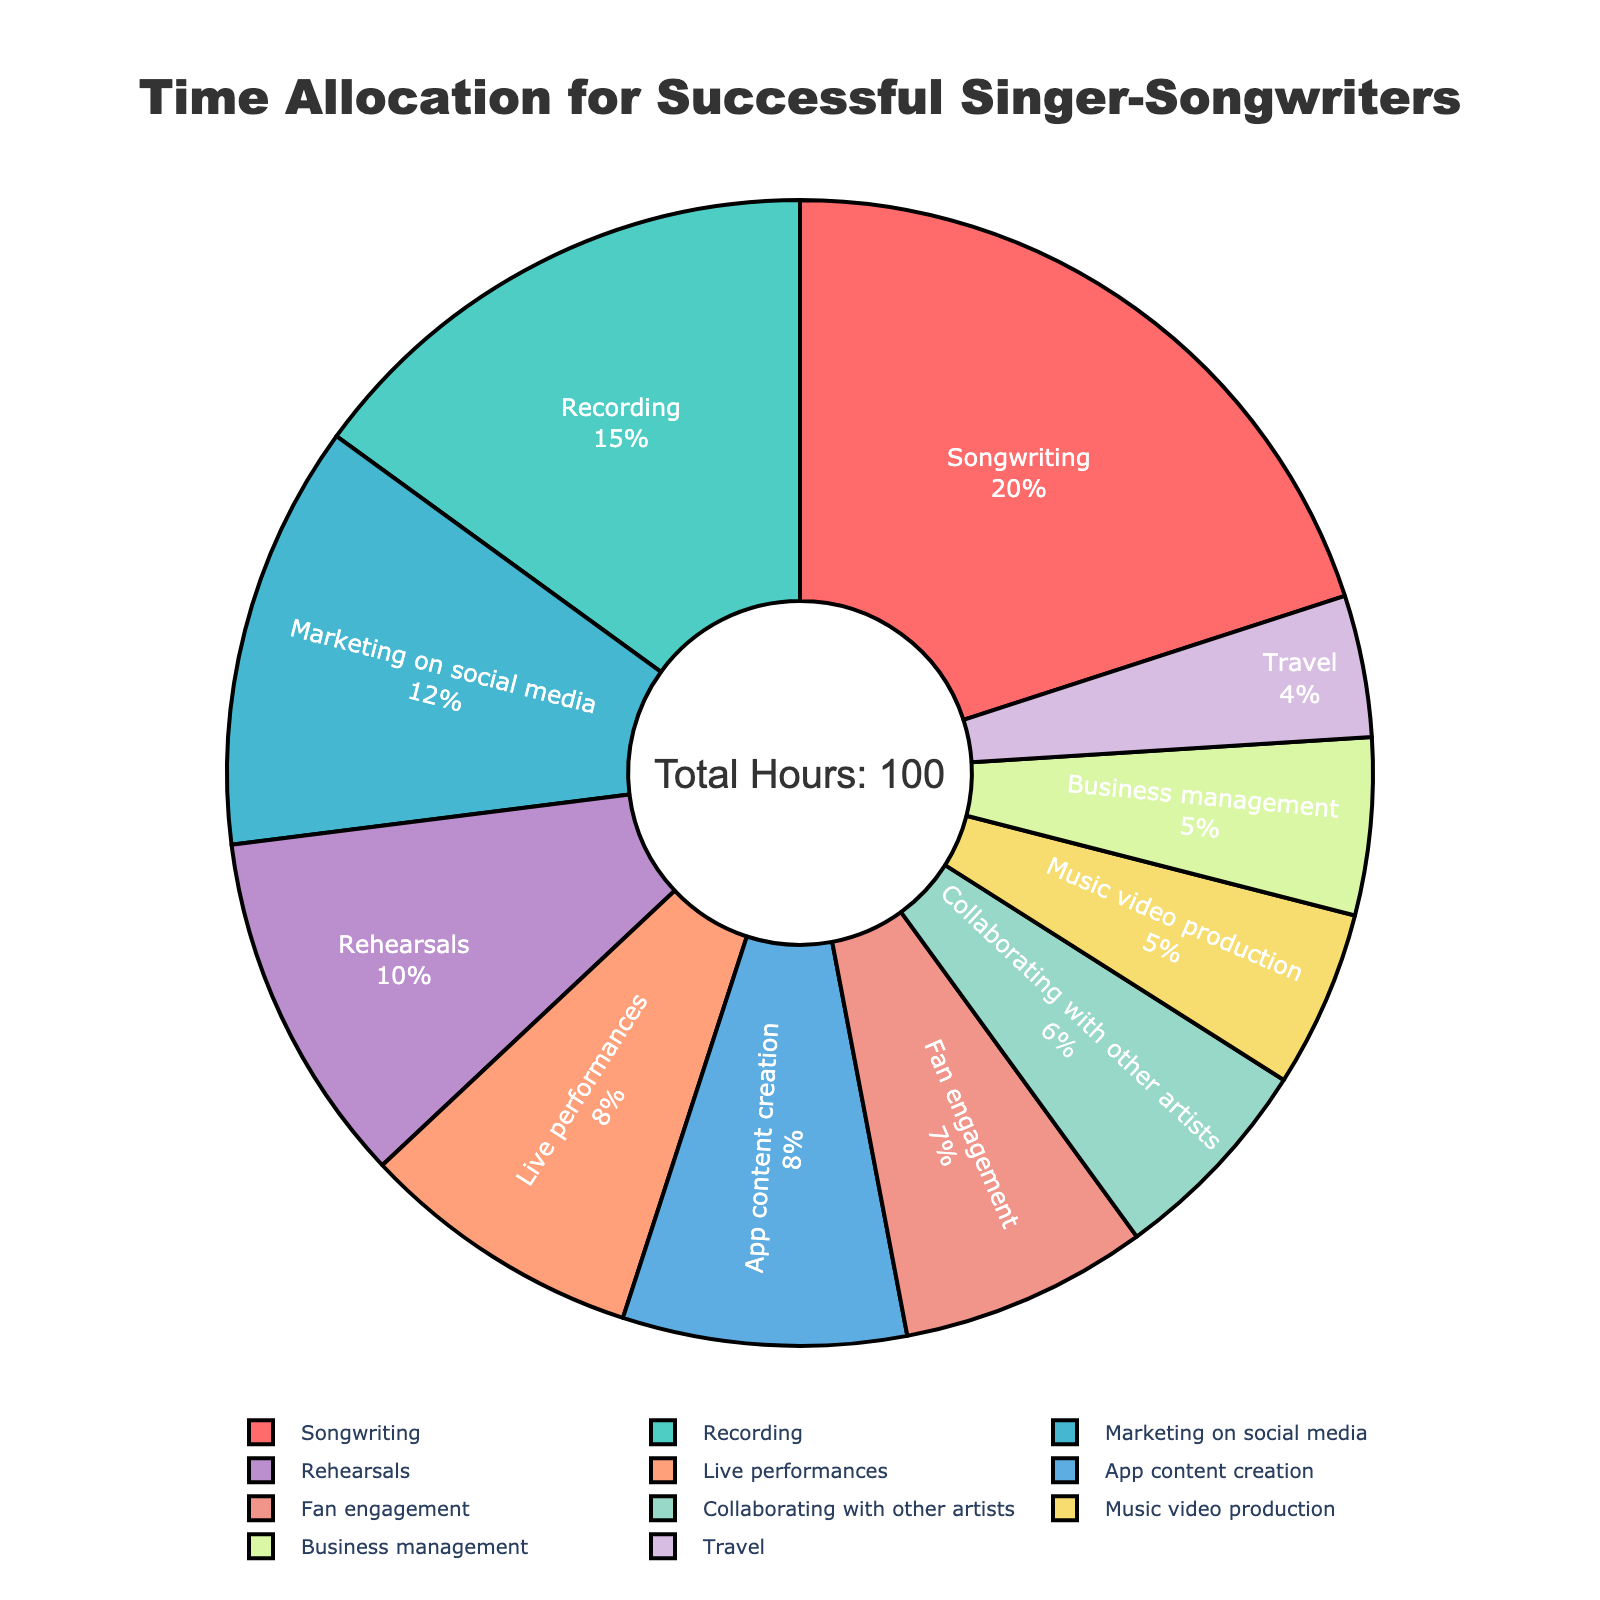Which activity takes up the most time in a typical week for singer-songwriters? By looking at the pie chart, we identify the section with the largest percentage. The label "Songwriting" has the largest portion, representing the highest number of hours.
Answer: Songwriting Which activity takes up the least time? We find the smallest segment of the pie chart by comparing all sections. The label "Travel" represents the smallest portion.
Answer: Travel How much more time is spent on songwriting compared to rehearsals? The writing time is 20 hours and rehearsals are 10 hours. Subtracting them gives 20 - 10 = 10 hours more.
Answer: 10 hours What is the combined percentage of time spent on fan engagement and app content creation? The chart shows the percentages for each segment. Adding fan engagement (7 hours) and app content creation (8 hours) out of 100 total hours gives (7 + 8) / 100 = 15%.
Answer: 15% How does the time allocated to performing compare to marketing on social media? The pie chart shows 8 hours for live performances and 12 hours for marketing. Hence, more hours are allocated to marketing.
Answer: Marketing Which activity is represented by the blue segment? By observing the color-coded sections, the blue segment corresponds with the "Recording" label.
Answer: Recording Is the total time spent on business management and travel more or less than music video production? Business management is 5 hours, travel is 4 hours, and music video production is 5 hours. Summing the first two gives 5+4=9, which is more than 5.
Answer: More What percentage of time is spent on collaborating with other artists? By looking at the pie chart, we find the section labeled "Collaborating with other artists" and annotate its percentage. This is 6%.
Answer: 6% List the top three activities in terms of time allocation. The chart shows the respective sizes. The three largest segments relate to songwriting (20 hours), recording (15 hours), and marketing on social media (12 hours).
Answer: Songwriting, Recording, Marketing on social media 